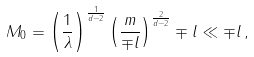<formula> <loc_0><loc_0><loc_500><loc_500>M _ { 0 } = \left ( \frac { 1 } { \lambda } \right ) ^ { \frac { 1 } { d - 2 } } \left ( \frac { m } { \mp l } \right ) ^ { \frac { 2 } { d - 2 } } \mp l \ll \mp l \, ,</formula> 